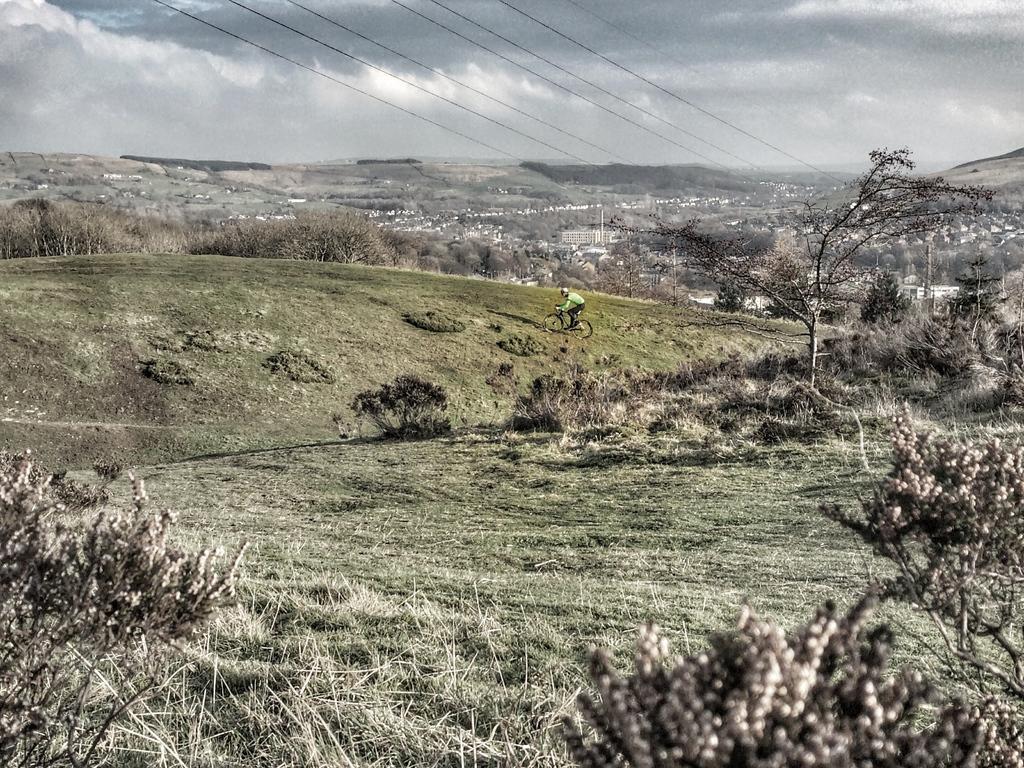Could you give a brief overview of what you see in this image? In this image we can see a person is riding a bike. There is a cloudy sky. There are many trees in the image. There is a grassy land in the image. 